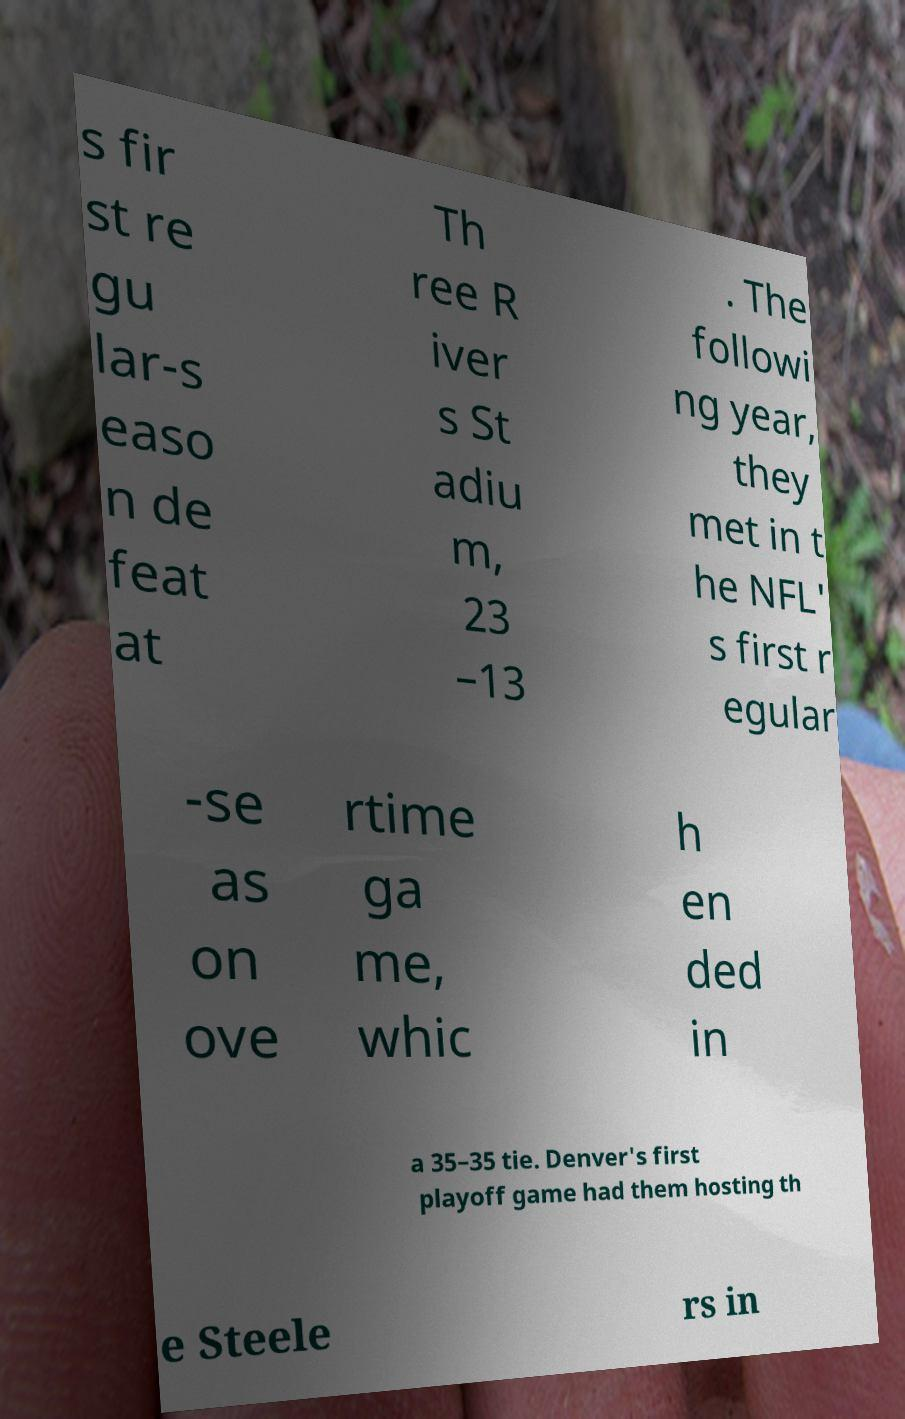For documentation purposes, I need the text within this image transcribed. Could you provide that? s fir st re gu lar-s easo n de feat at Th ree R iver s St adiu m, 23 –13 . The followi ng year, they met in t he NFL' s first r egular -se as on ove rtime ga me, whic h en ded in a 35–35 tie. Denver's first playoff game had them hosting th e Steele rs in 